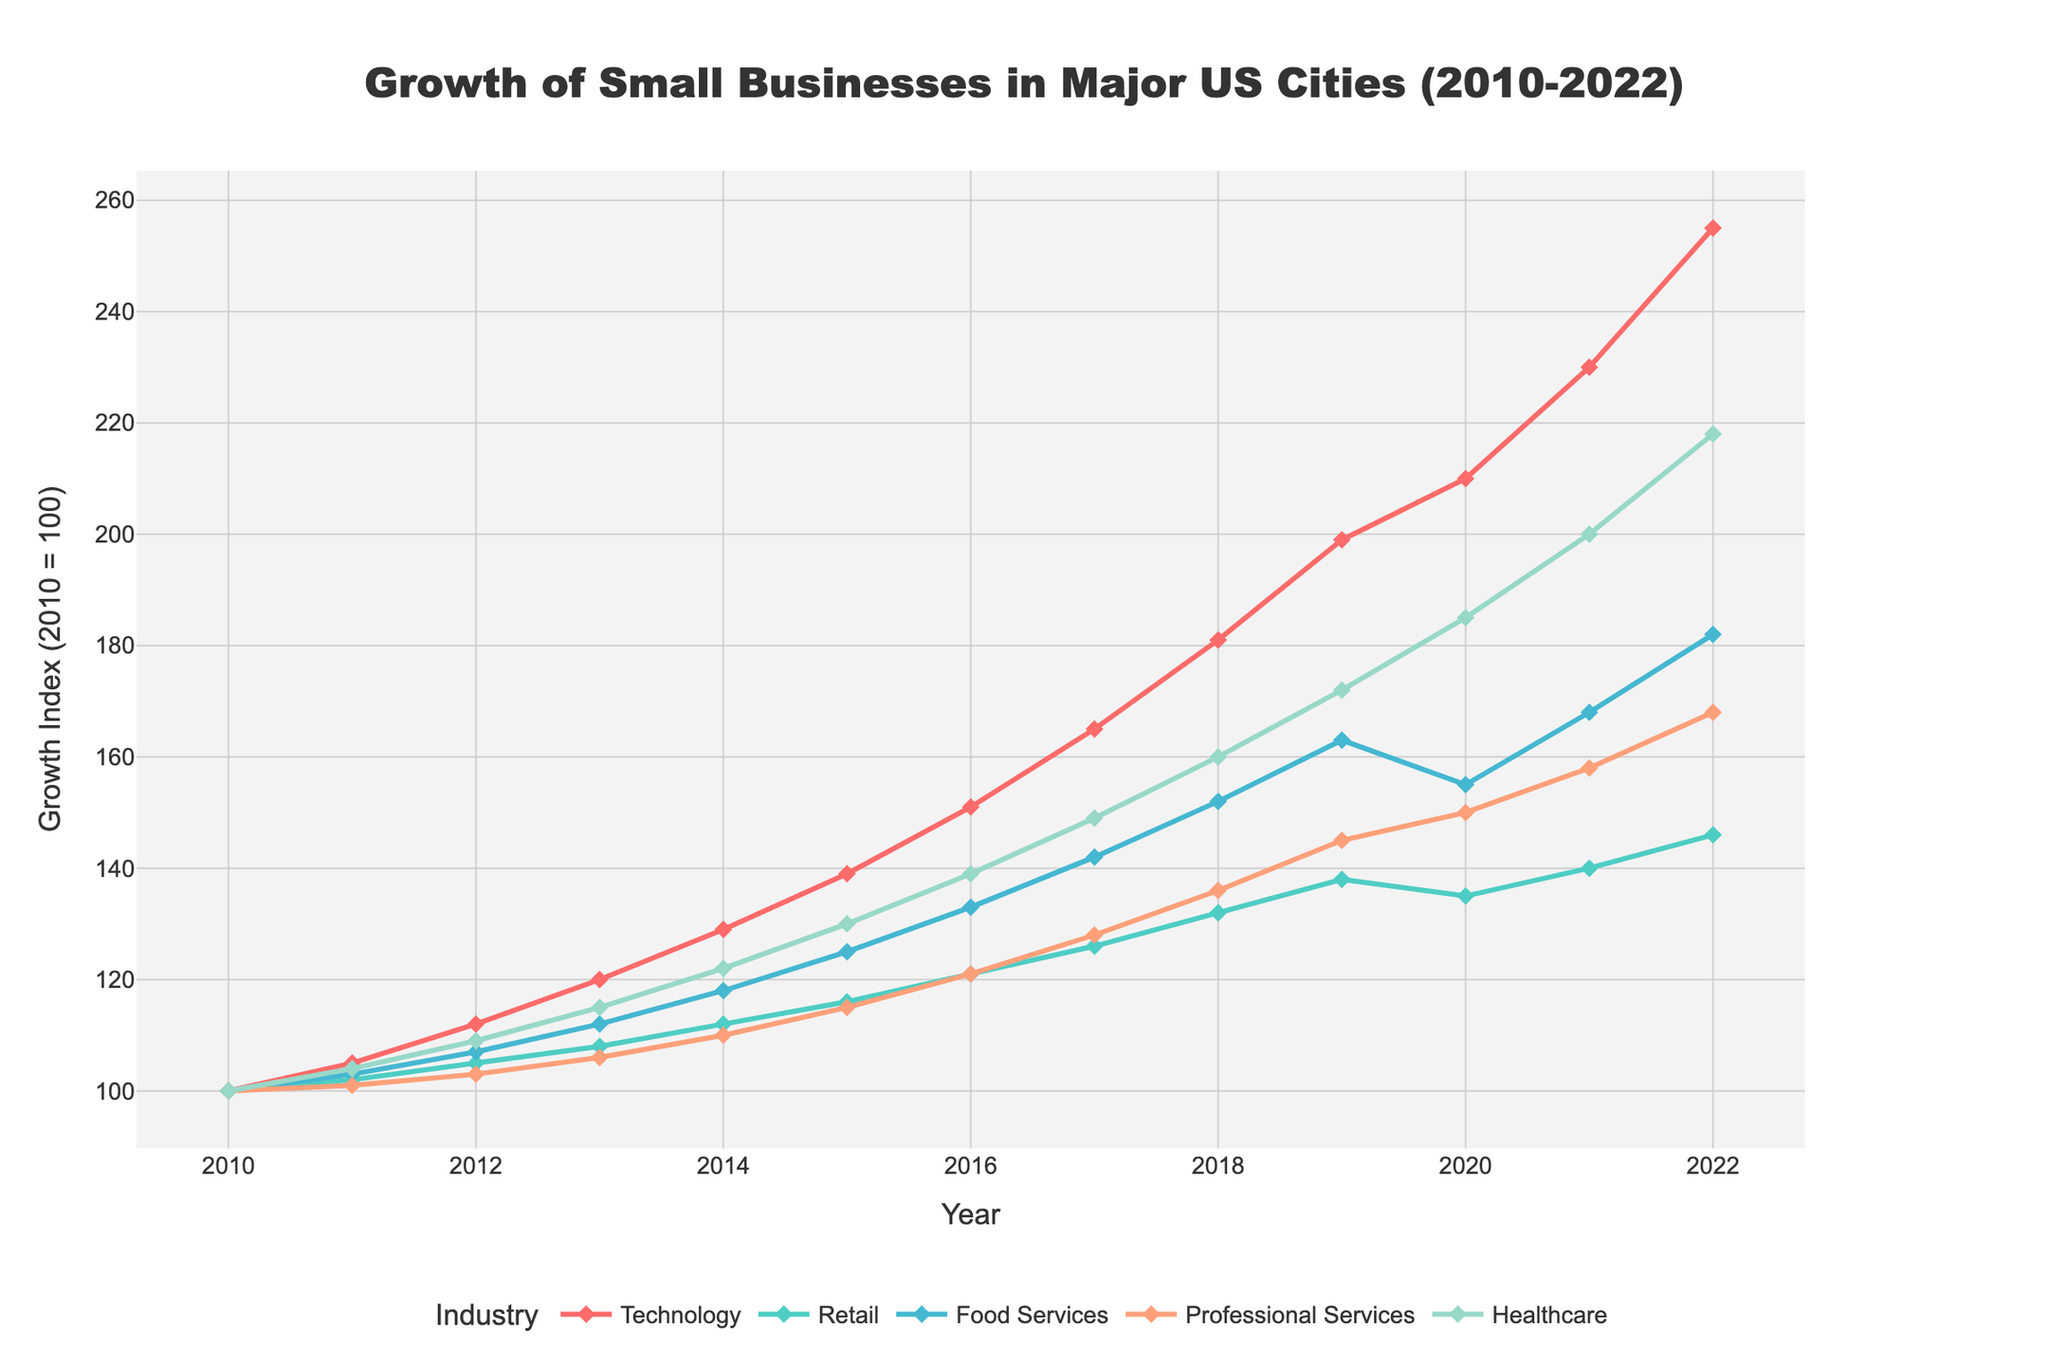What industry experienced the highest growth from 2010 to 2022? By comparing the endpoints of each line representing different industries in the chart, the Technology industry shows the highest increase from 100 in 2010 to 255 in 2022.
Answer: Technology Which industry had a decline in growth from 2019 to 2020? Observing the trend lines in the graph, the Retail industry's growth index decreased from 138 in 2019 to 135 in 2020.
Answer: Retail Compare the growth rates of Technology and Healthcare industries in 2022. Which one is higher, and by how much? The Technology industry's index in 2022 is 255, while the Healthcare industry's index is 218. Subtracting these values shows that Technology's growth is higher by 37 points.
Answer: Technology, by 37 points In what year did Professional Services surpass a growth index of 150? The Professional Services line crosses the 150 index mark between 2020 and 2021 and continues to rise in 2022.
Answer: 2021 Among all years, which year did Food Services see the highest growth increase compared to the previous year? By evaluating the differences in the Food Services line year-over-year, the largest increase is between 2021 (168) and 2022 (182). This increase is 14 points.
Answer: 2022 What was the gap in the growth index between the Technology and Retail industries in 2014? In 2014, Technology had an index of 129 and Retail had an index of 112. The difference is 129 - 112 = 17.
Answer: 17 Which industry has the most consistent growth trend over the years? The Healthcare industry line shows the most gradual and consistent upward slope without sharp increases or decreases from 2010 to 2022.
Answer: Healthcare Compare the growth index of Professional Services between 2016 and 2018. What is the percentage increase? The growth index of Professional Services increased from 121 in 2016 to 136 in 2018. The percentage increase is ((136 - 121) / 121) * 100 = 12.4%.
Answer: 12.4% Across the whole period, which industry showed the least growth and by how much did it grow? Comparing all lines from start to end, Retail shows the least growth from 100 in 2010 to 146 in 2022, growing by 46 points.
Answer: Retail, by 46 points Which industry had a period of stagnation or decline, and in what years did it occur? The Food Services industry had a period of stagnation and slight decline from 2019 (163) to 2020 (155) before rising again.
Answer: Food Services, 2019-2020 